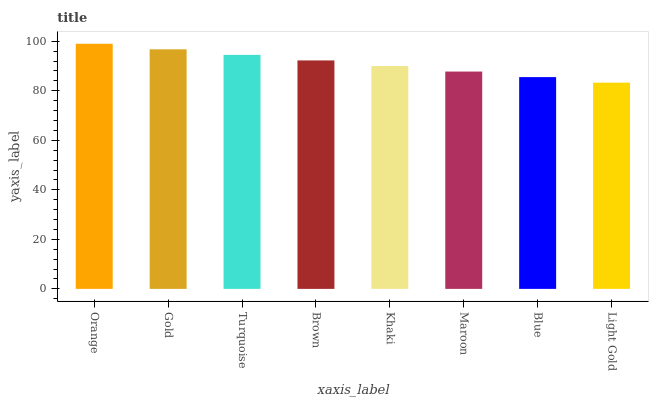Is Light Gold the minimum?
Answer yes or no. Yes. Is Orange the maximum?
Answer yes or no. Yes. Is Gold the minimum?
Answer yes or no. No. Is Gold the maximum?
Answer yes or no. No. Is Orange greater than Gold?
Answer yes or no. Yes. Is Gold less than Orange?
Answer yes or no. Yes. Is Gold greater than Orange?
Answer yes or no. No. Is Orange less than Gold?
Answer yes or no. No. Is Brown the high median?
Answer yes or no. Yes. Is Khaki the low median?
Answer yes or no. Yes. Is Gold the high median?
Answer yes or no. No. Is Gold the low median?
Answer yes or no. No. 